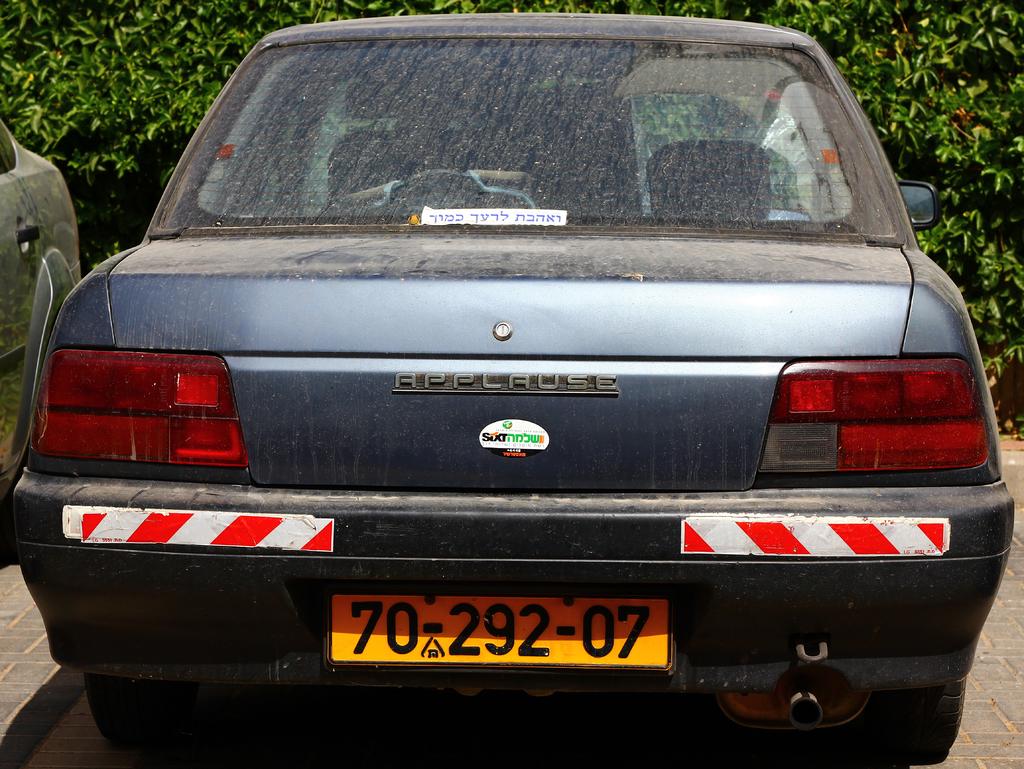Which two numbers appear at the beginning and at the end of the license plate?
Provide a short and direct response. 70. What car brand is this?
Provide a succinct answer. Applause. 